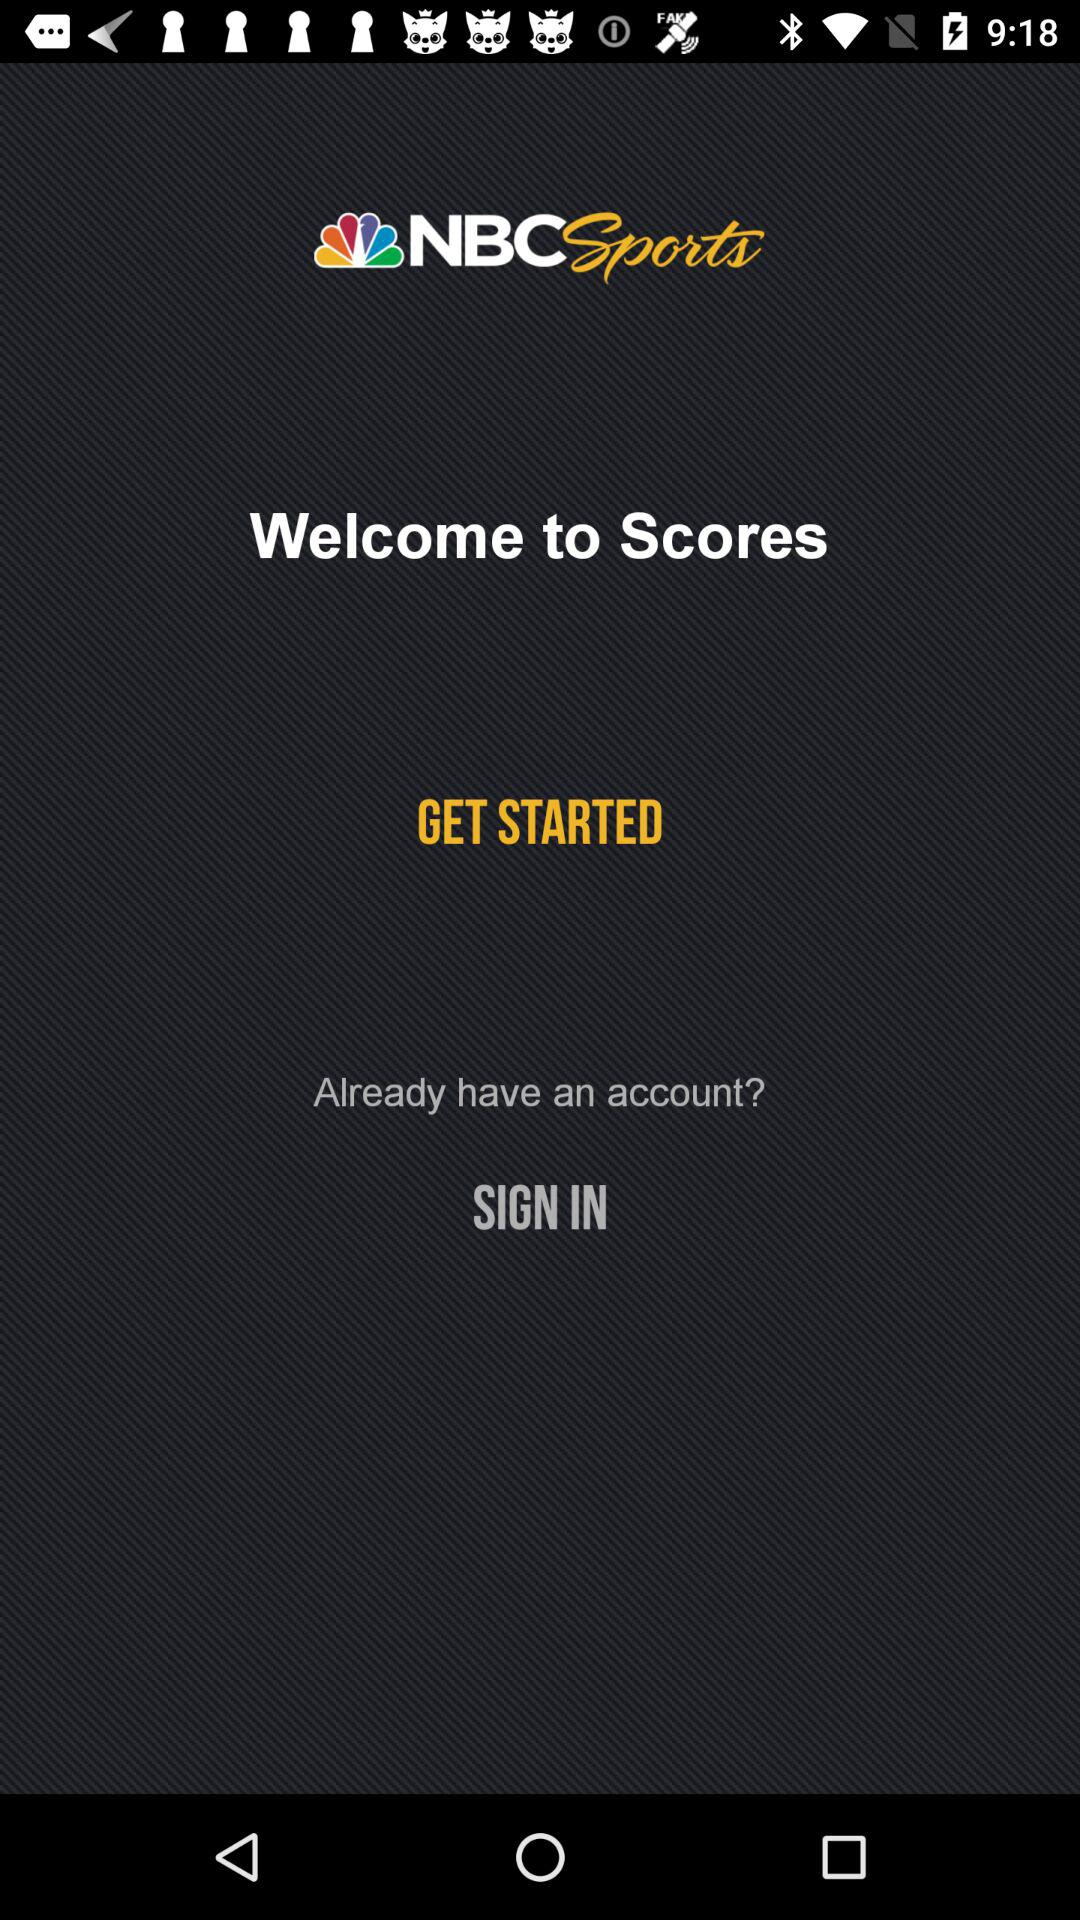What is the name of the application? The name of the application is "NBCSports". 